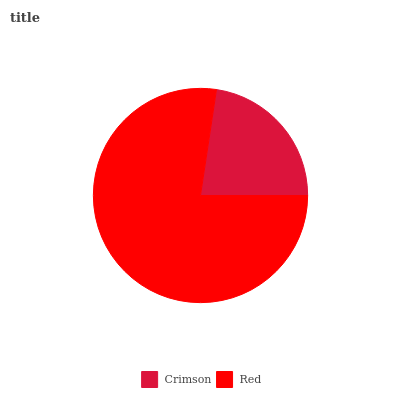Is Crimson the minimum?
Answer yes or no. Yes. Is Red the maximum?
Answer yes or no. Yes. Is Red the minimum?
Answer yes or no. No. Is Red greater than Crimson?
Answer yes or no. Yes. Is Crimson less than Red?
Answer yes or no. Yes. Is Crimson greater than Red?
Answer yes or no. No. Is Red less than Crimson?
Answer yes or no. No. Is Red the high median?
Answer yes or no. Yes. Is Crimson the low median?
Answer yes or no. Yes. Is Crimson the high median?
Answer yes or no. No. Is Red the low median?
Answer yes or no. No. 